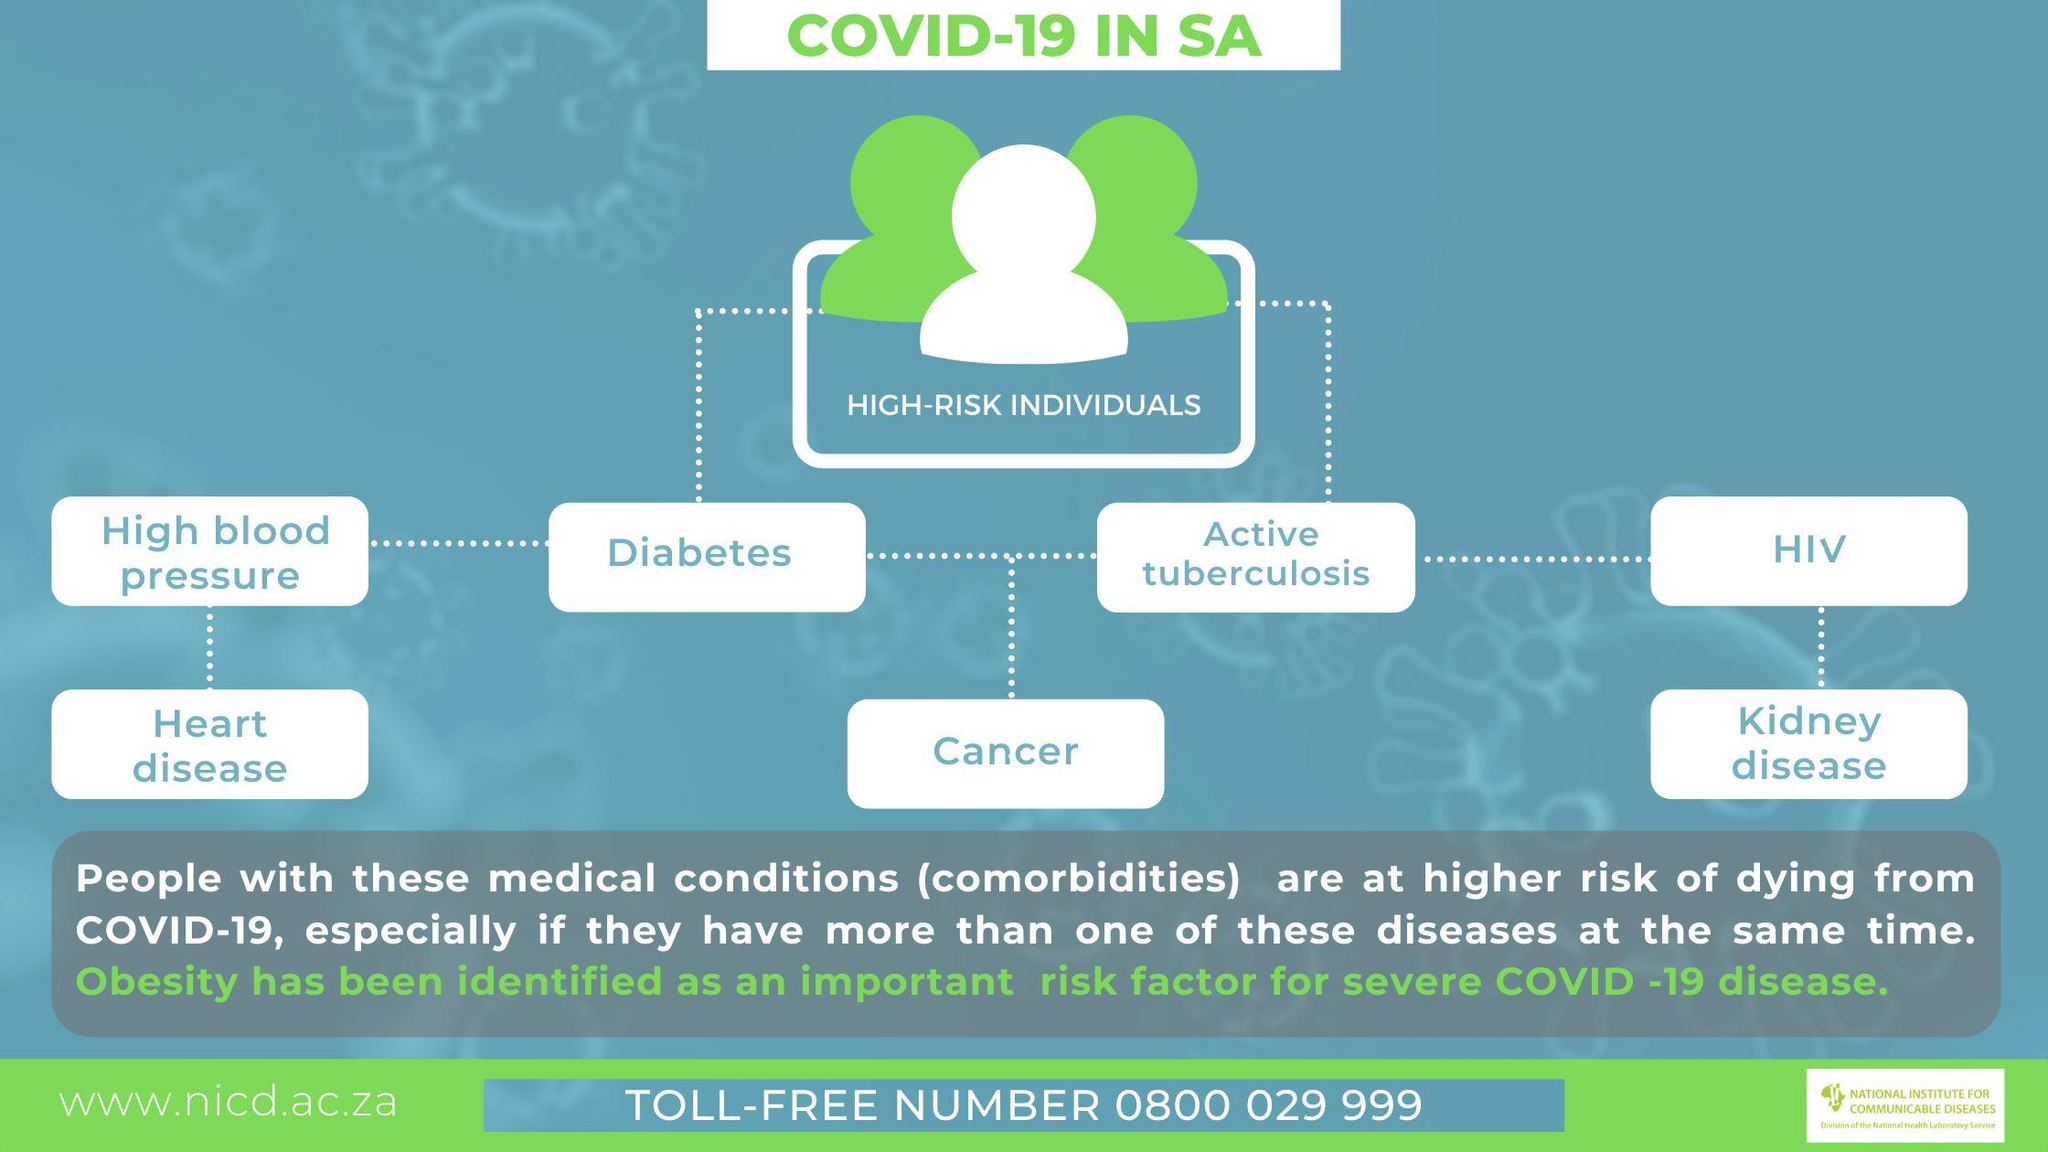Which disease is given just left to HIV?
Answer the question with a short phrase. active tuberculosis Which disease is given just right to high blood pressure? diabetes Which disease is given in the middle of heart disease and kidney disease? cancer how many medical conditions are given in the chart? 7 how many diseases are given in the first row of the chart? 4 What is the color of the text in the heading "COVID-19 IN SA" - green, yellow or blue? green how many diseases are given in the second row of the chart? 3 